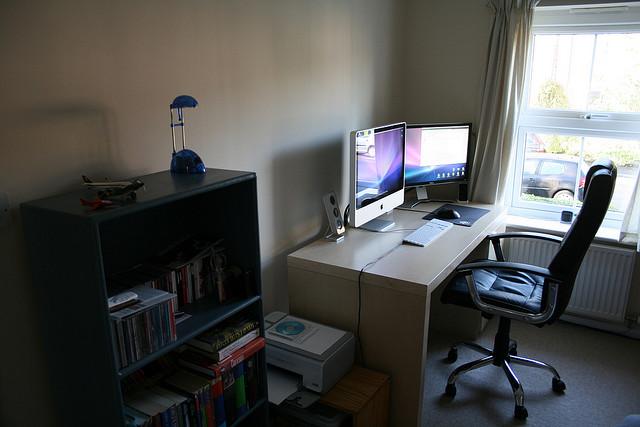Is that a mac?
Keep it brief. Yes. How many monitors are on the desk?
Quick response, please. 2. Are the monitors turned on?
Answer briefly. Yes. 